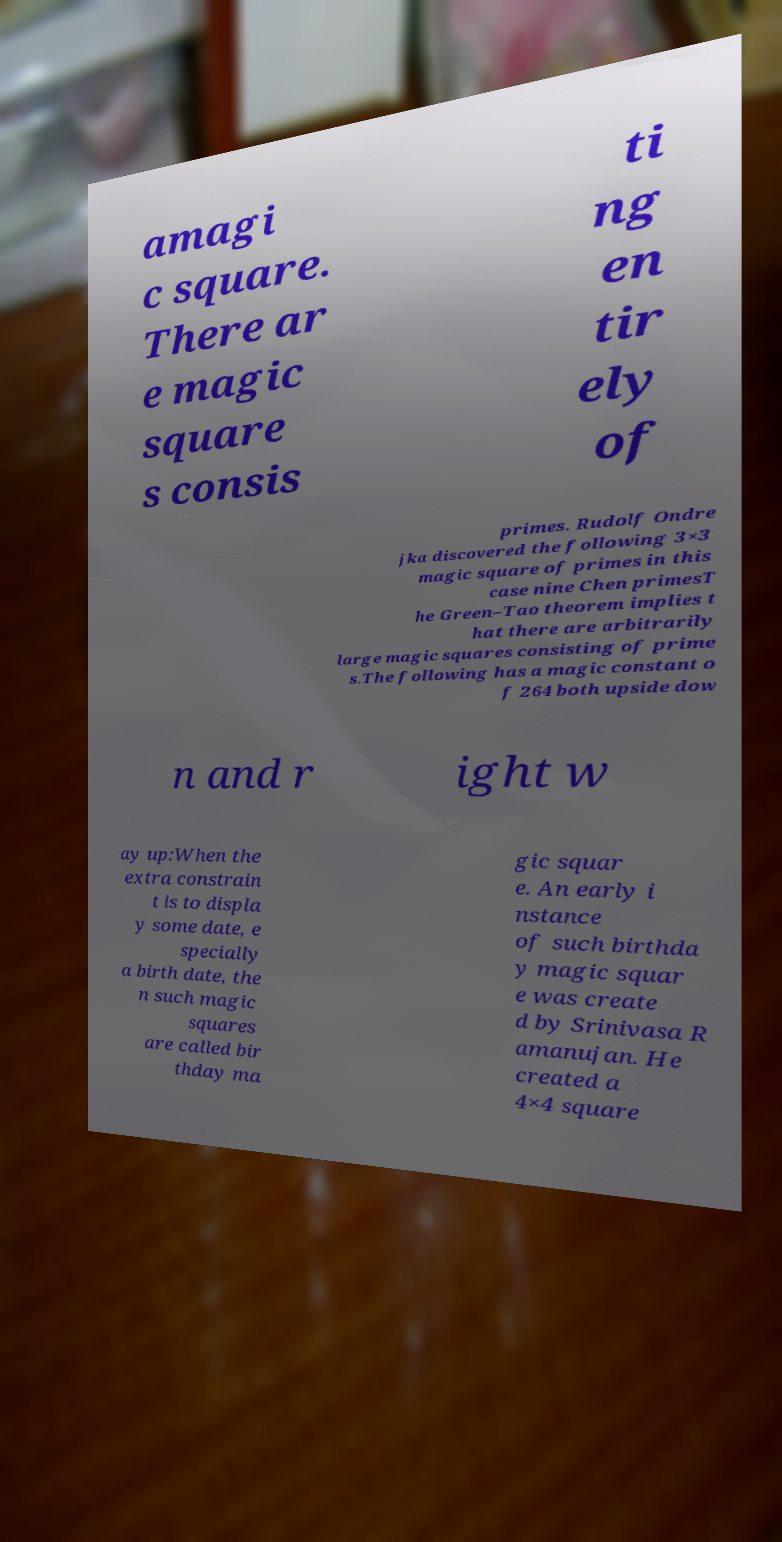Please identify and transcribe the text found in this image. amagi c square. There ar e magic square s consis ti ng en tir ely of primes. Rudolf Ondre jka discovered the following 3×3 magic square of primes in this case nine Chen primesT he Green–Tao theorem implies t hat there are arbitrarily large magic squares consisting of prime s.The following has a magic constant o f 264 both upside dow n and r ight w ay up:When the extra constrain t is to displa y some date, e specially a birth date, the n such magic squares are called bir thday ma gic squar e. An early i nstance of such birthda y magic squar e was create d by Srinivasa R amanujan. He created a 4×4 square 